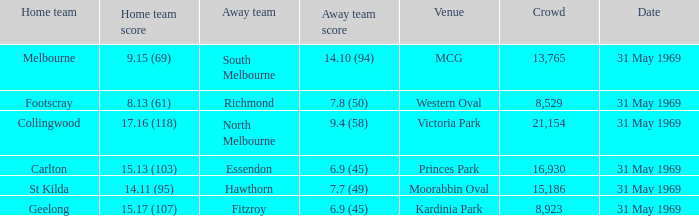Which domestic team tallied 1 St Kilda. 